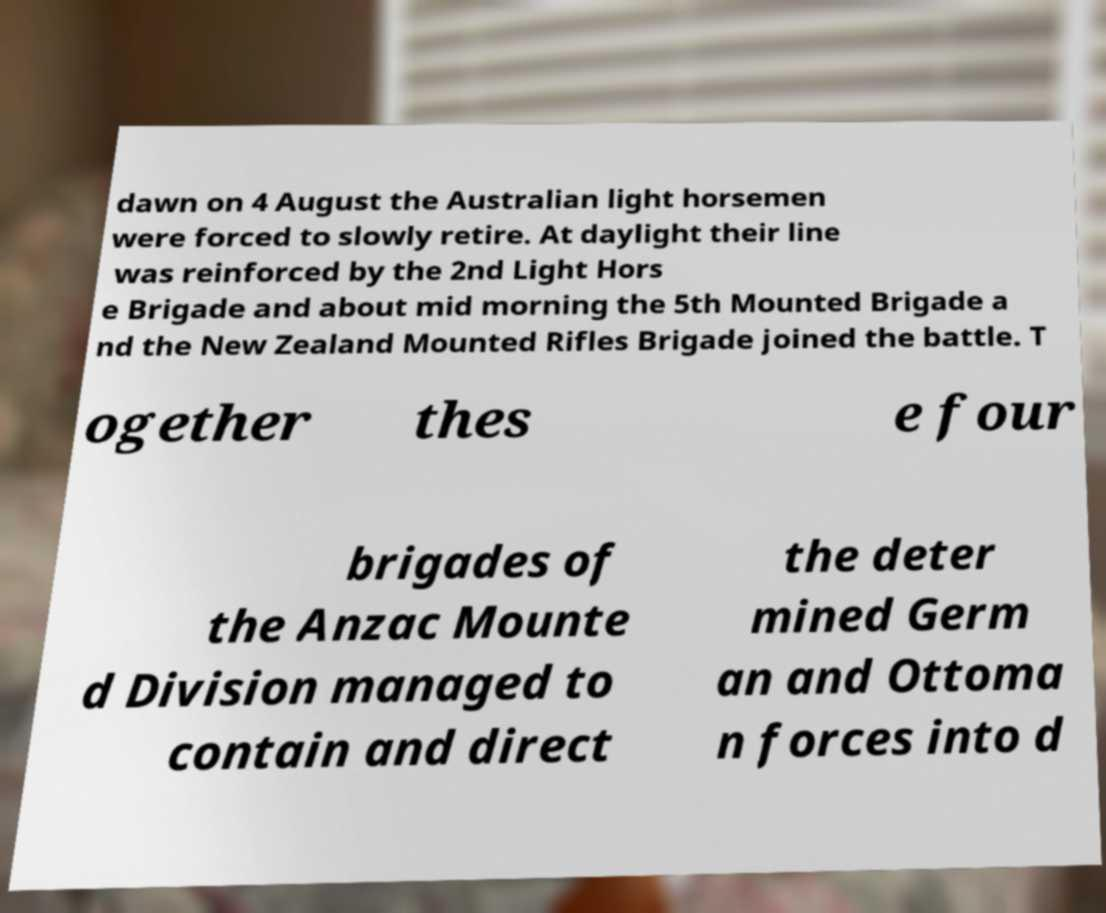Please read and relay the text visible in this image. What does it say? dawn on 4 August the Australian light horsemen were forced to slowly retire. At daylight their line was reinforced by the 2nd Light Hors e Brigade and about mid morning the 5th Mounted Brigade a nd the New Zealand Mounted Rifles Brigade joined the battle. T ogether thes e four brigades of the Anzac Mounte d Division managed to contain and direct the deter mined Germ an and Ottoma n forces into d 